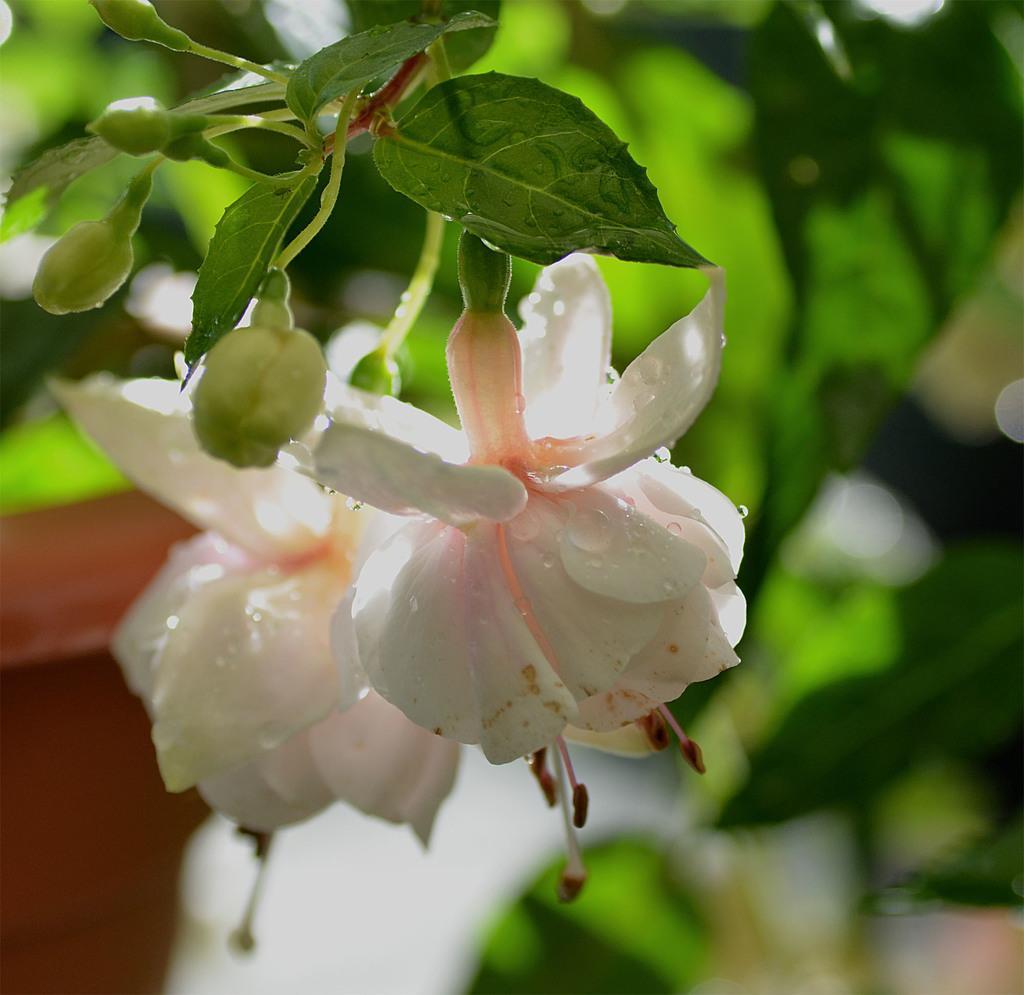Could you give a brief overview of what you see in this image? In this image I can see few white colour flowers and few green colour leaves in the front. In the background I can see green colour things, a brown colour thing and I can see this image is little bit blurry in the background. 